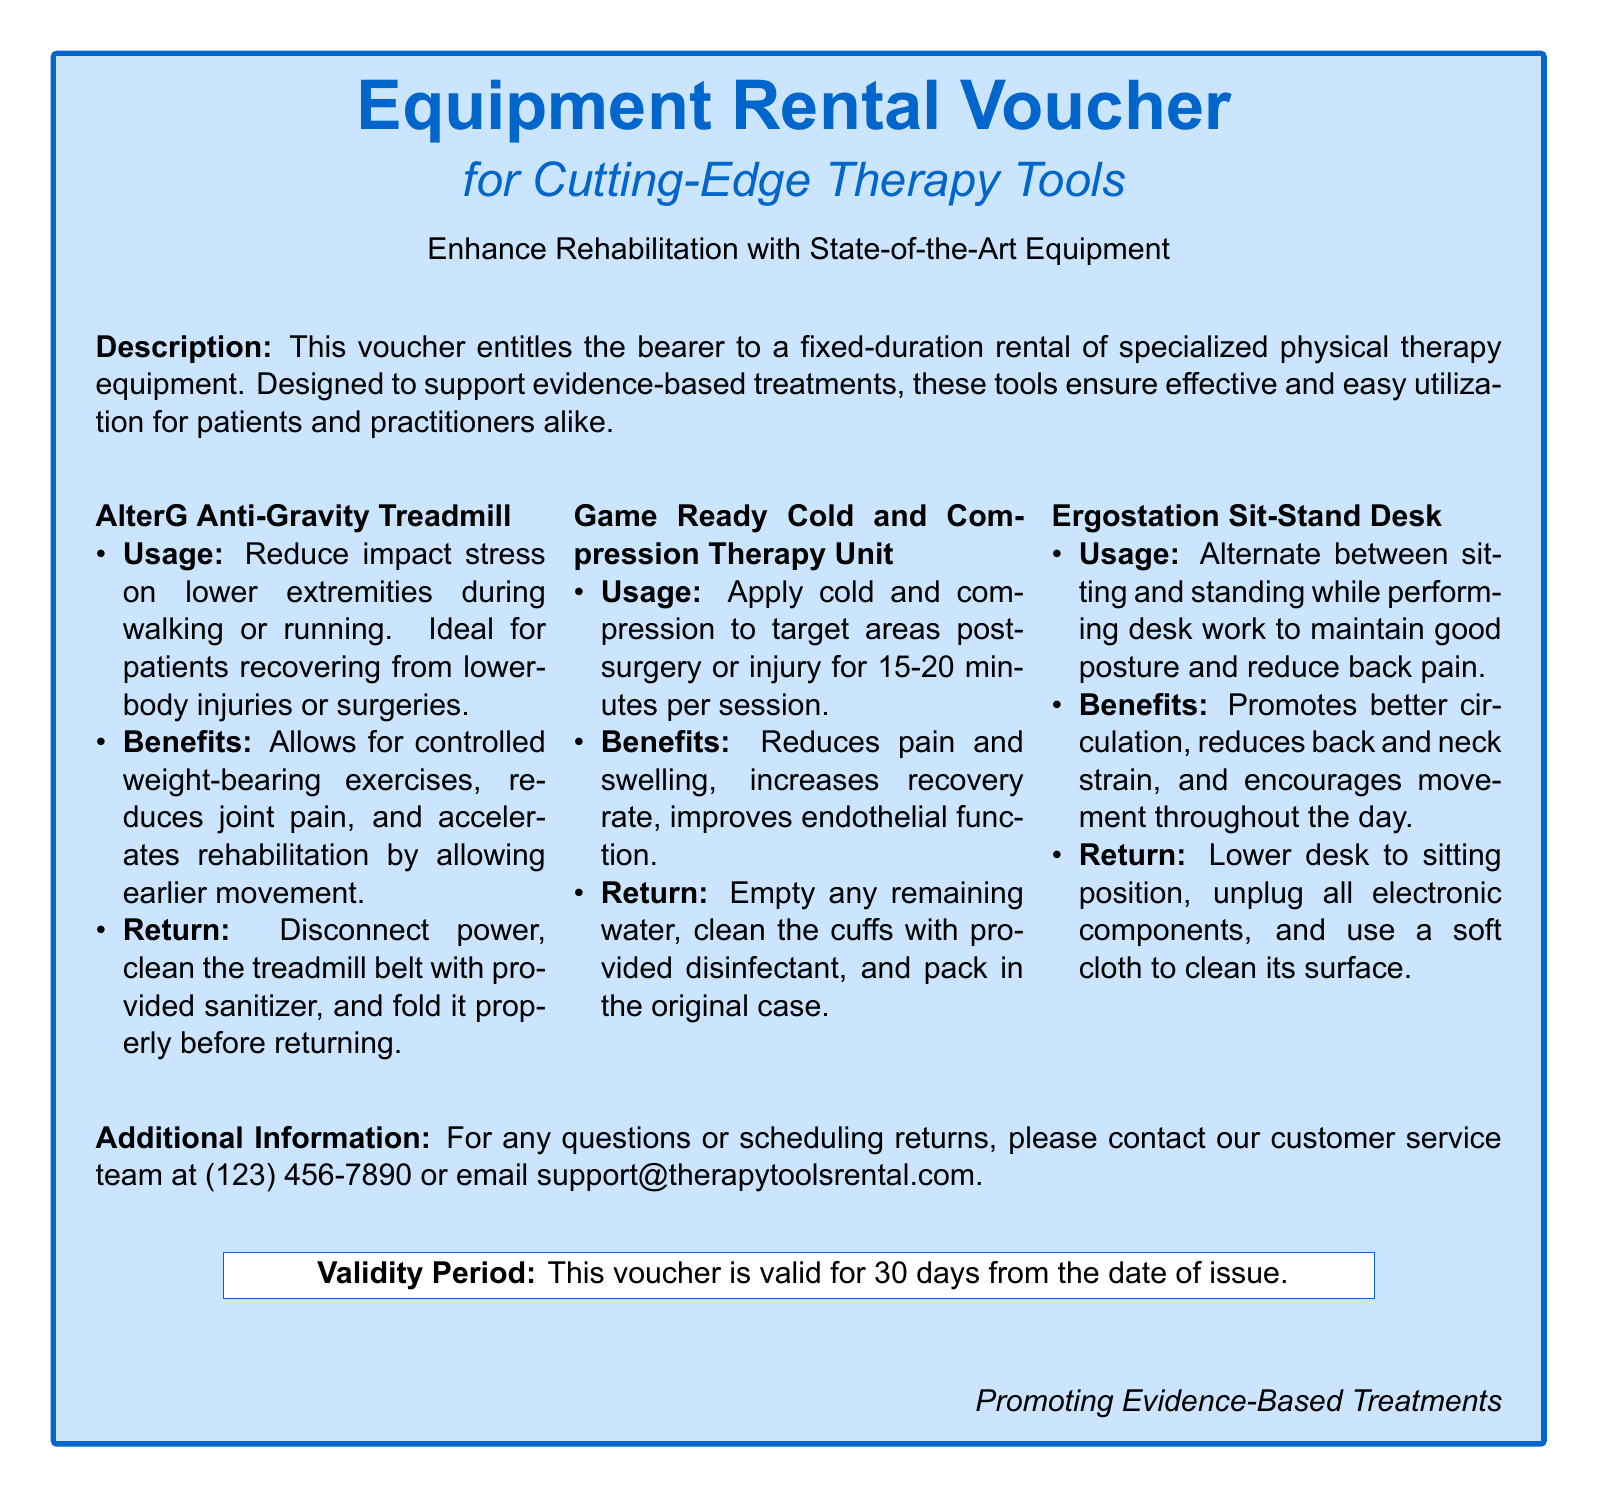What is the purpose of the voucher? The voucher entitles the bearer to a fixed-duration rental of specialized physical therapy equipment.
Answer: Fixed-duration rental of specialized physical therapy equipment How long is the validity period of the voucher? The validity period is mentioned explicitly at the bottom of the document, stating it is valid for 30 days.
Answer: 30 days What is the first tool listed in the document? The first tool mentioned is the AlterG Anti-Gravity Treadmill in the equipment section.
Answer: AlterG Anti-Gravity Treadmill What are the benefits of the Game Ready Cold and Compression Therapy Unit? The document outlines the benefits connected to this tool, such as reducing pain and swelling and increasing recovery rate.
Answer: Reduces pain and swelling, increases recovery rate What should you do before returning the Ergostation Sit-Stand Desk? The document provides return instructions, specifically stating to lower the desk to the sitting position.
Answer: Lower desk to sitting position Why is the AlterG Anti-Gravity Treadmill recommended? The document elaborates on its ideal use case, specifically mentioning it is ideal for recovering patients.
Answer: Recovering from lower-body injuries or surgeries How to contact customer service for any inquiries? Contact details are included in the document, specifically mentioning a phone number and email.
Answer: (123) 456-7890 or support@therapytoolsrental.com What should be done with the Game Ready Cold and Compression Therapy Unit before returning? The return instructions indicate that any remaining water should be emptied before returning the unit.
Answer: Empty any remaining water What type of therapy does this equipment rental voucher support? The document implies that the equipment rental supports therapies that are based on scientific evidence.
Answer: Evidence-based treatments 